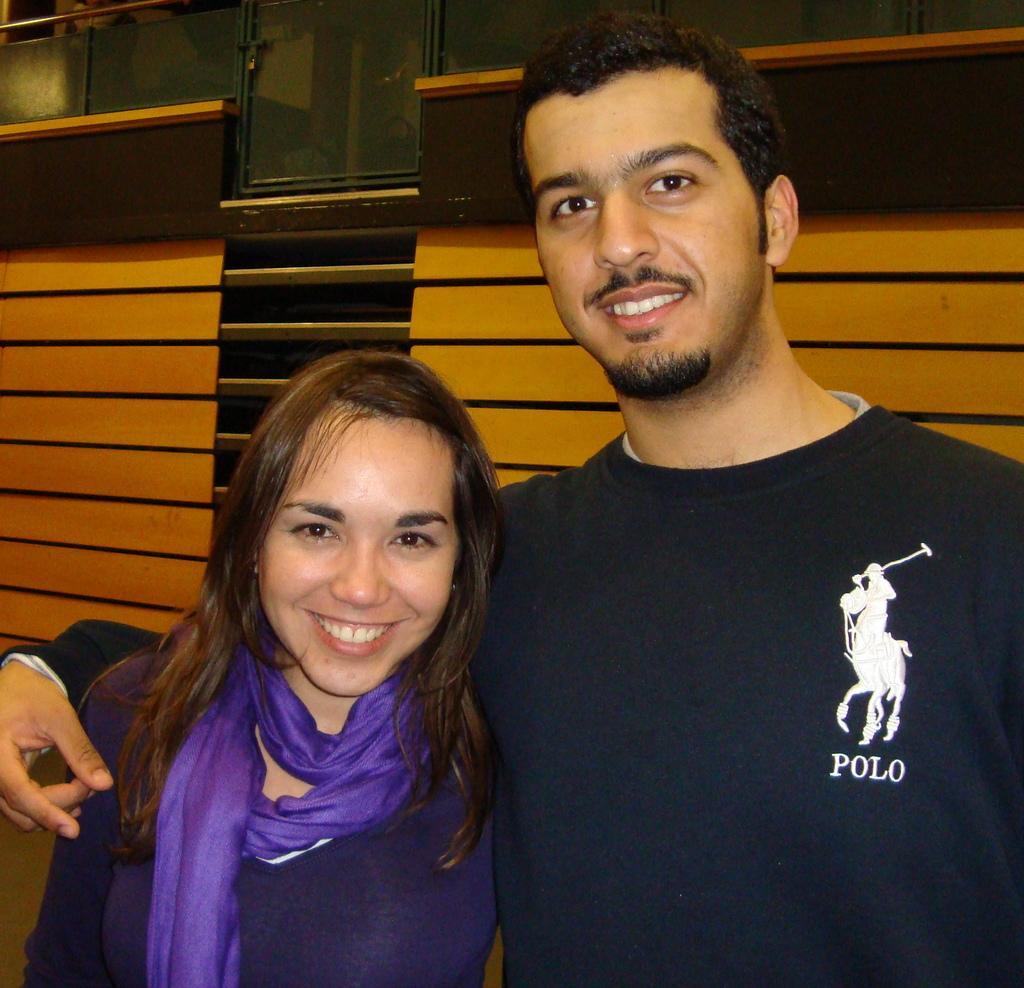Can you describe this image briefly? In the picture we can see a man and a woman standing together and smiling and man is wearing a black T-shirt and woman is wearing a blue dress with a cloth and behind them we can see a wooden planks wall and on top of it we can see a small glass door. 